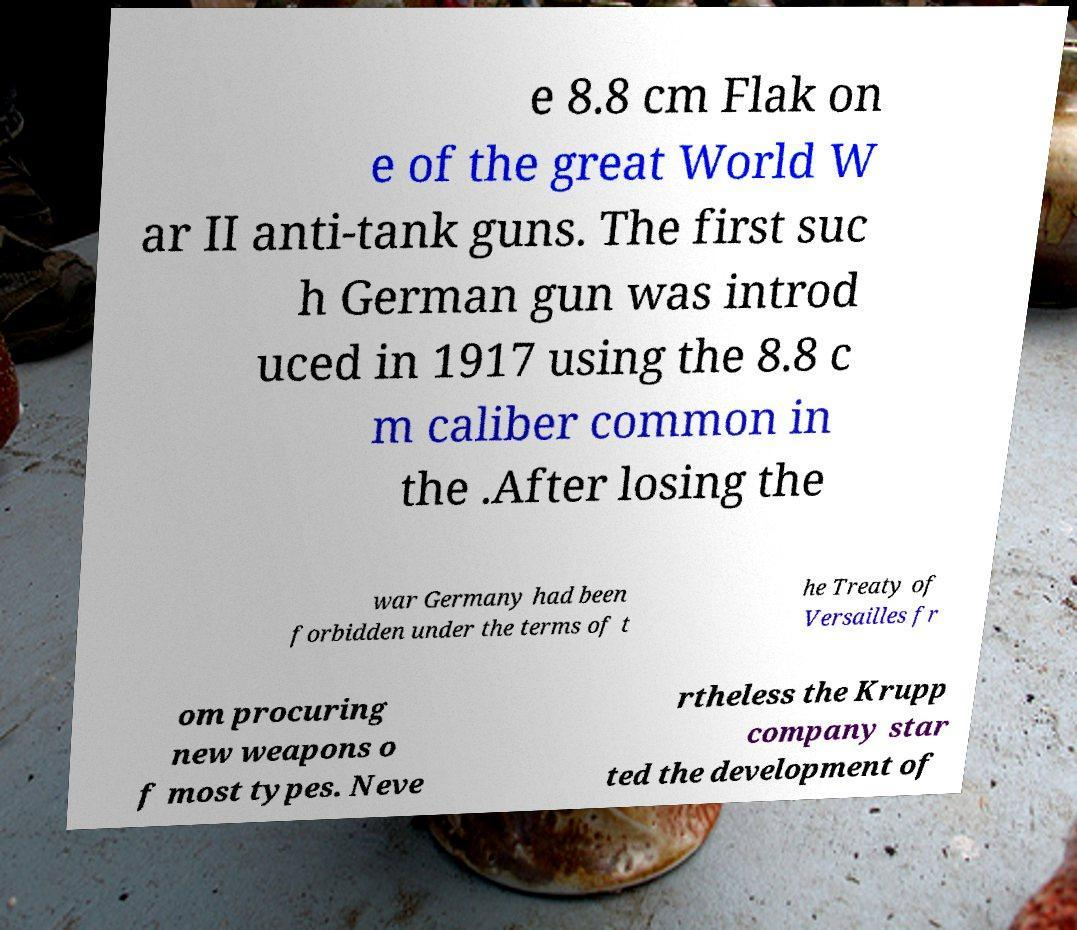I need the written content from this picture converted into text. Can you do that? e 8.8 cm Flak on e of the great World W ar II anti-tank guns. The first suc h German gun was introd uced in 1917 using the 8.8 c m caliber common in the .After losing the war Germany had been forbidden under the terms of t he Treaty of Versailles fr om procuring new weapons o f most types. Neve rtheless the Krupp company star ted the development of 